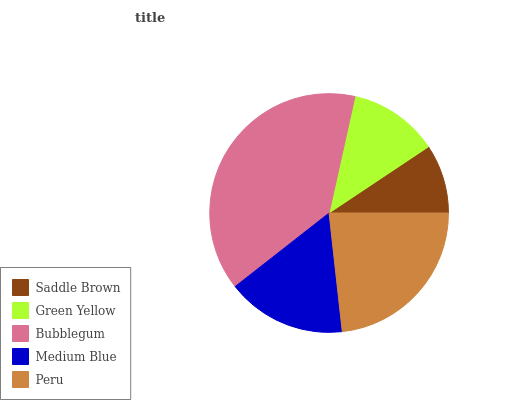Is Saddle Brown the minimum?
Answer yes or no. Yes. Is Bubblegum the maximum?
Answer yes or no. Yes. Is Green Yellow the minimum?
Answer yes or no. No. Is Green Yellow the maximum?
Answer yes or no. No. Is Green Yellow greater than Saddle Brown?
Answer yes or no. Yes. Is Saddle Brown less than Green Yellow?
Answer yes or no. Yes. Is Saddle Brown greater than Green Yellow?
Answer yes or no. No. Is Green Yellow less than Saddle Brown?
Answer yes or no. No. Is Medium Blue the high median?
Answer yes or no. Yes. Is Medium Blue the low median?
Answer yes or no. Yes. Is Green Yellow the high median?
Answer yes or no. No. Is Peru the low median?
Answer yes or no. No. 